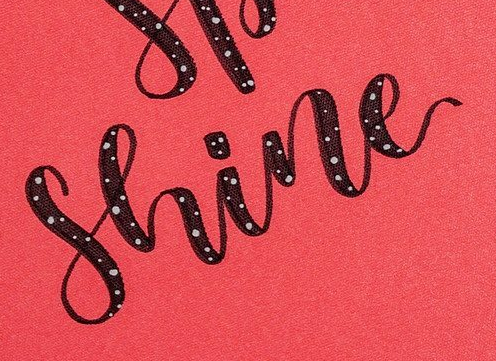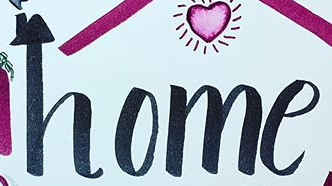Transcribe the words shown in these images in order, separated by a semicolon. Shine; home 